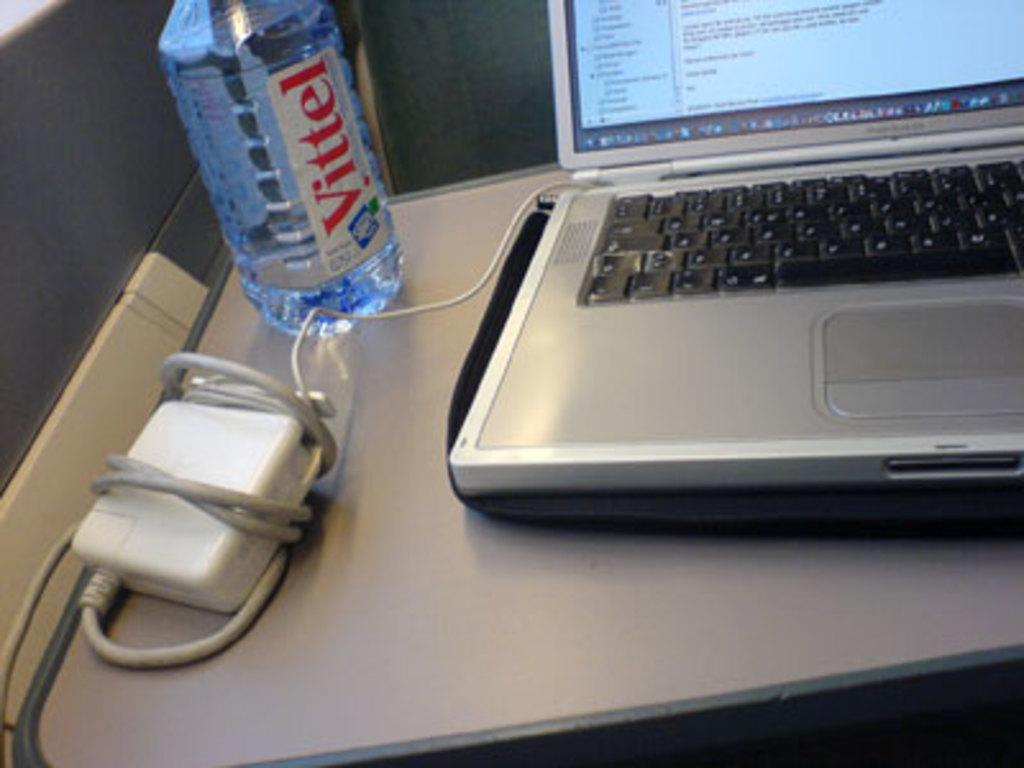<image>
Offer a succinct explanation of the picture presented. A mostly empty bottle of Vittel sits next to an open laptop. 